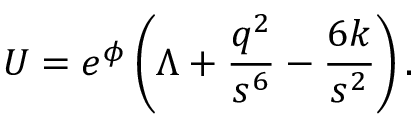Convert formula to latex. <formula><loc_0><loc_0><loc_500><loc_500>U = e ^ { \phi } \left ( \Lambda + \frac { q ^ { 2 } } { s ^ { 6 } } - \frac { 6 k } { s ^ { 2 } } \right ) .</formula> 